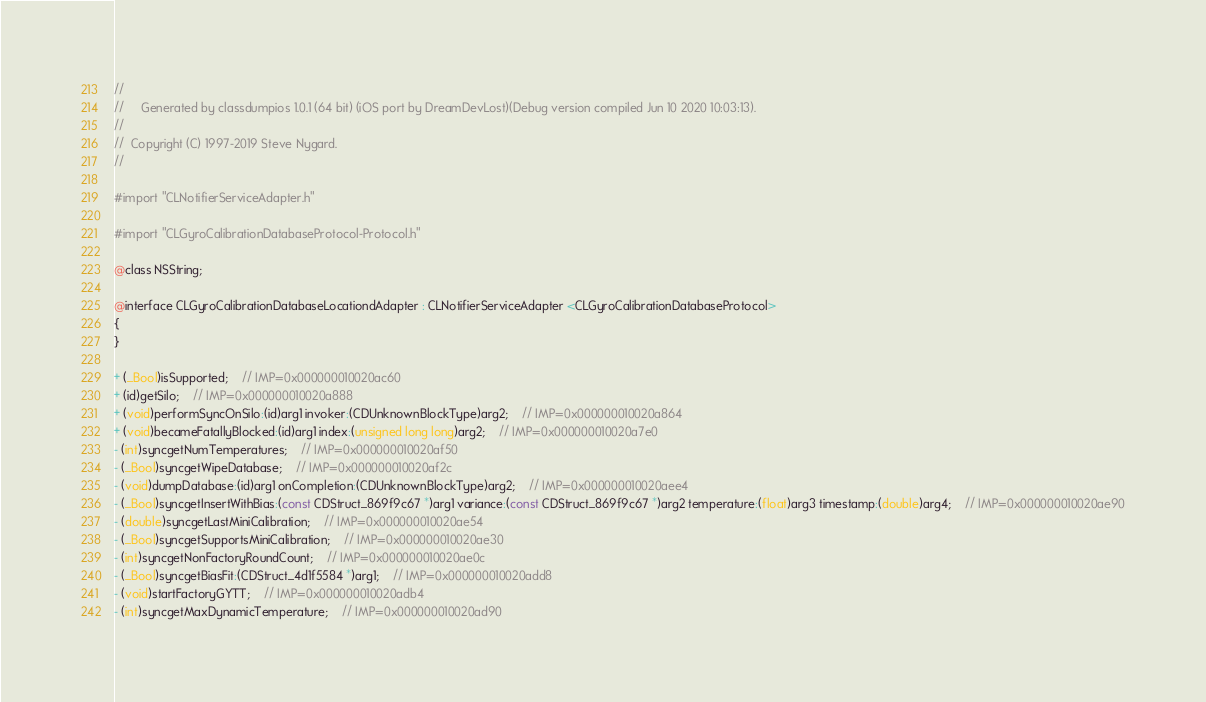Convert code to text. <code><loc_0><loc_0><loc_500><loc_500><_C_>//
//     Generated by classdumpios 1.0.1 (64 bit) (iOS port by DreamDevLost)(Debug version compiled Jun 10 2020 10:03:13).
//
//  Copyright (C) 1997-2019 Steve Nygard.
//

#import "CLNotifierServiceAdapter.h"

#import "CLGyroCalibrationDatabaseProtocol-Protocol.h"

@class NSString;

@interface CLGyroCalibrationDatabaseLocationdAdapter : CLNotifierServiceAdapter <CLGyroCalibrationDatabaseProtocol>
{
}

+ (_Bool)isSupported;	// IMP=0x000000010020ac60
+ (id)getSilo;	// IMP=0x000000010020a888
+ (void)performSyncOnSilo:(id)arg1 invoker:(CDUnknownBlockType)arg2;	// IMP=0x000000010020a864
+ (void)becameFatallyBlocked:(id)arg1 index:(unsigned long long)arg2;	// IMP=0x000000010020a7e0
- (int)syncgetNumTemperatures;	// IMP=0x000000010020af50
- (_Bool)syncgetWipeDatabase;	// IMP=0x000000010020af2c
- (void)dumpDatabase:(id)arg1 onCompletion:(CDUnknownBlockType)arg2;	// IMP=0x000000010020aee4
- (_Bool)syncgetInsertWithBias:(const CDStruct_869f9c67 *)arg1 variance:(const CDStruct_869f9c67 *)arg2 temperature:(float)arg3 timestamp:(double)arg4;	// IMP=0x000000010020ae90
- (double)syncgetLastMiniCalibration;	// IMP=0x000000010020ae54
- (_Bool)syncgetSupportsMiniCalibration;	// IMP=0x000000010020ae30
- (int)syncgetNonFactoryRoundCount;	// IMP=0x000000010020ae0c
- (_Bool)syncgetBiasFit:(CDStruct_4d1f5584 *)arg1;	// IMP=0x000000010020add8
- (void)startFactoryGYTT;	// IMP=0x000000010020adb4
- (int)syncgetMaxDynamicTemperature;	// IMP=0x000000010020ad90</code> 